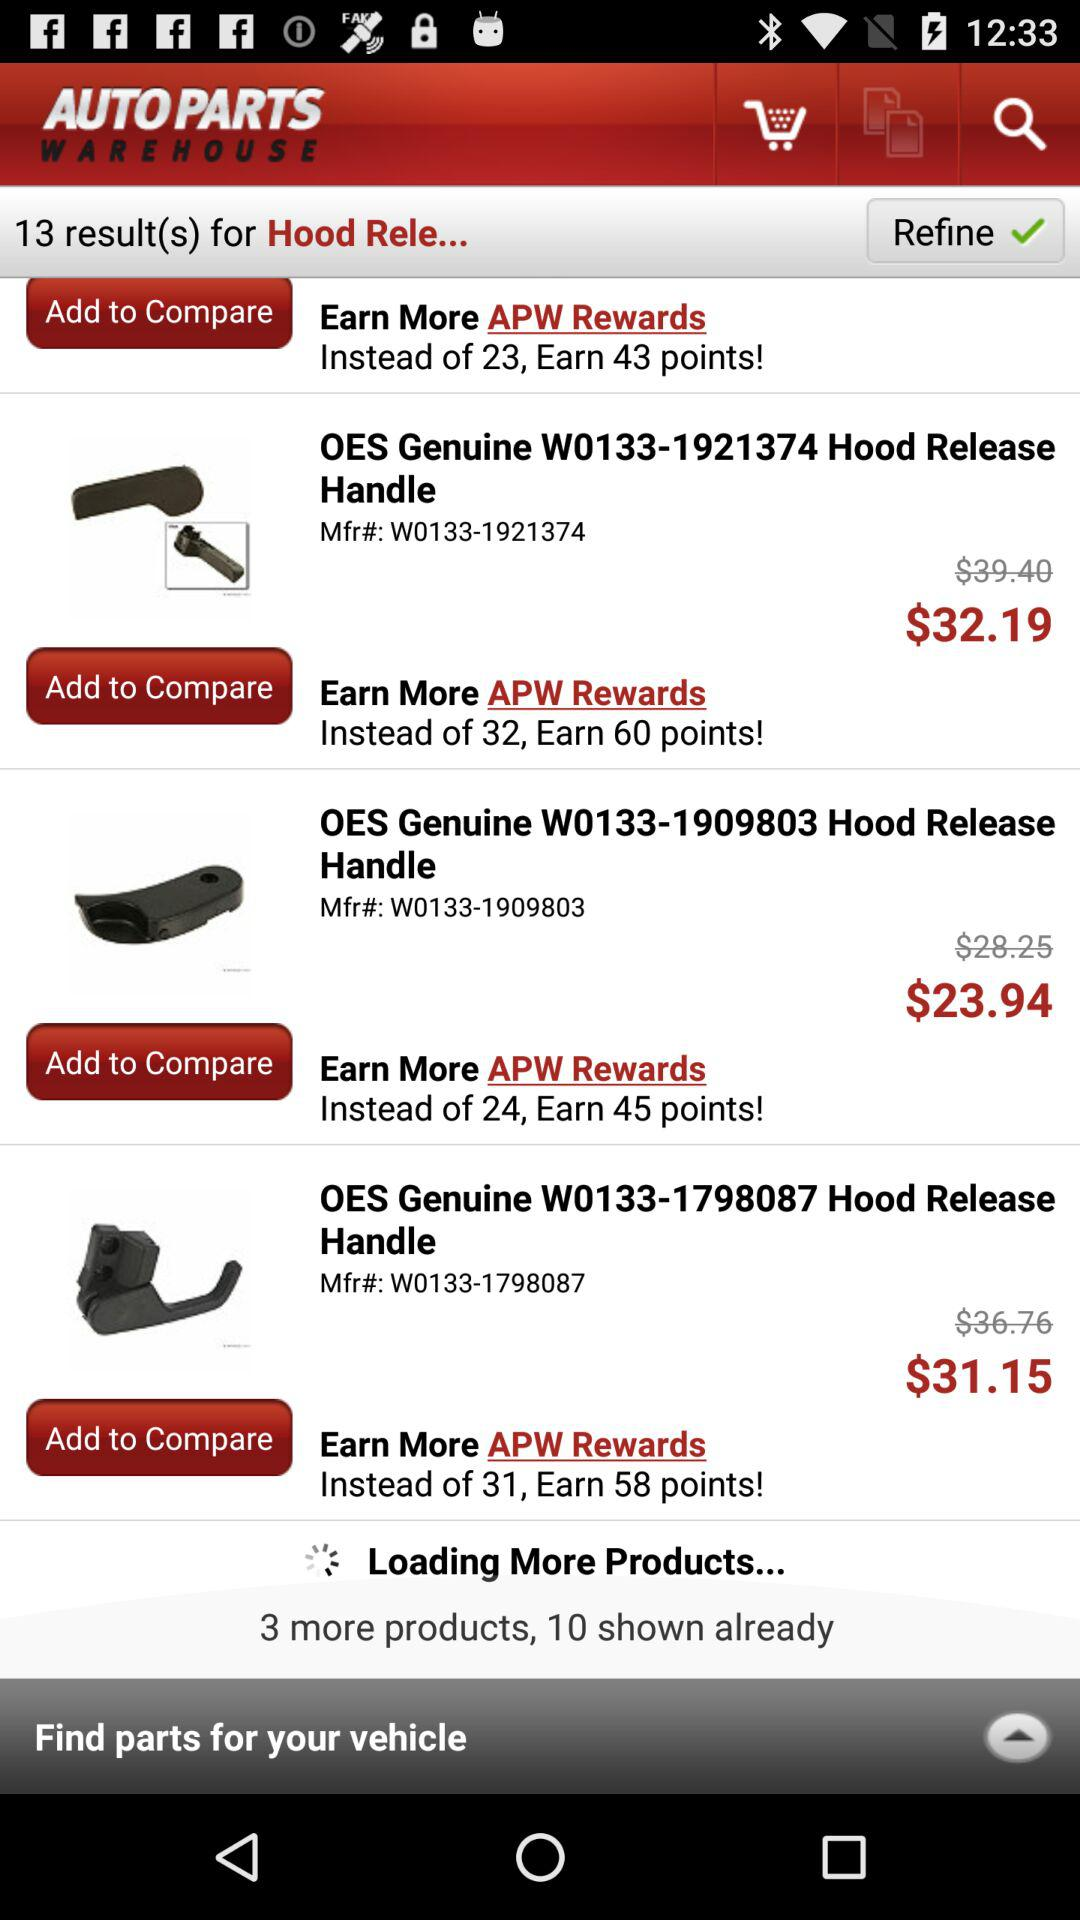How many products are shown already?
Answer the question using a single word or phrase. 10 